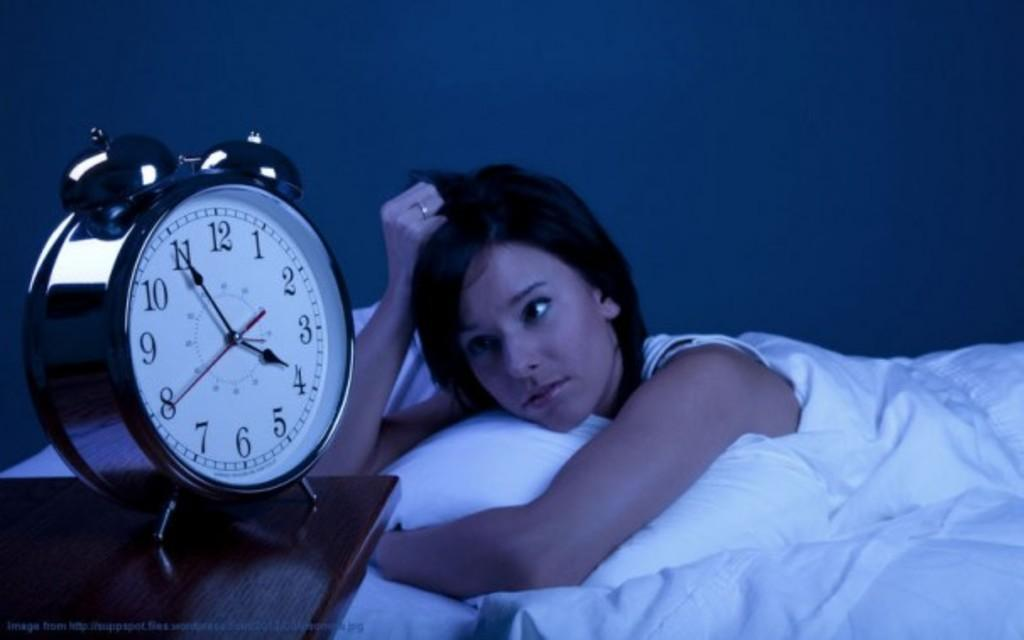<image>
Provide a brief description of the given image. A white clock reads that it is 3:55 a.m. while a person lies in bed. 